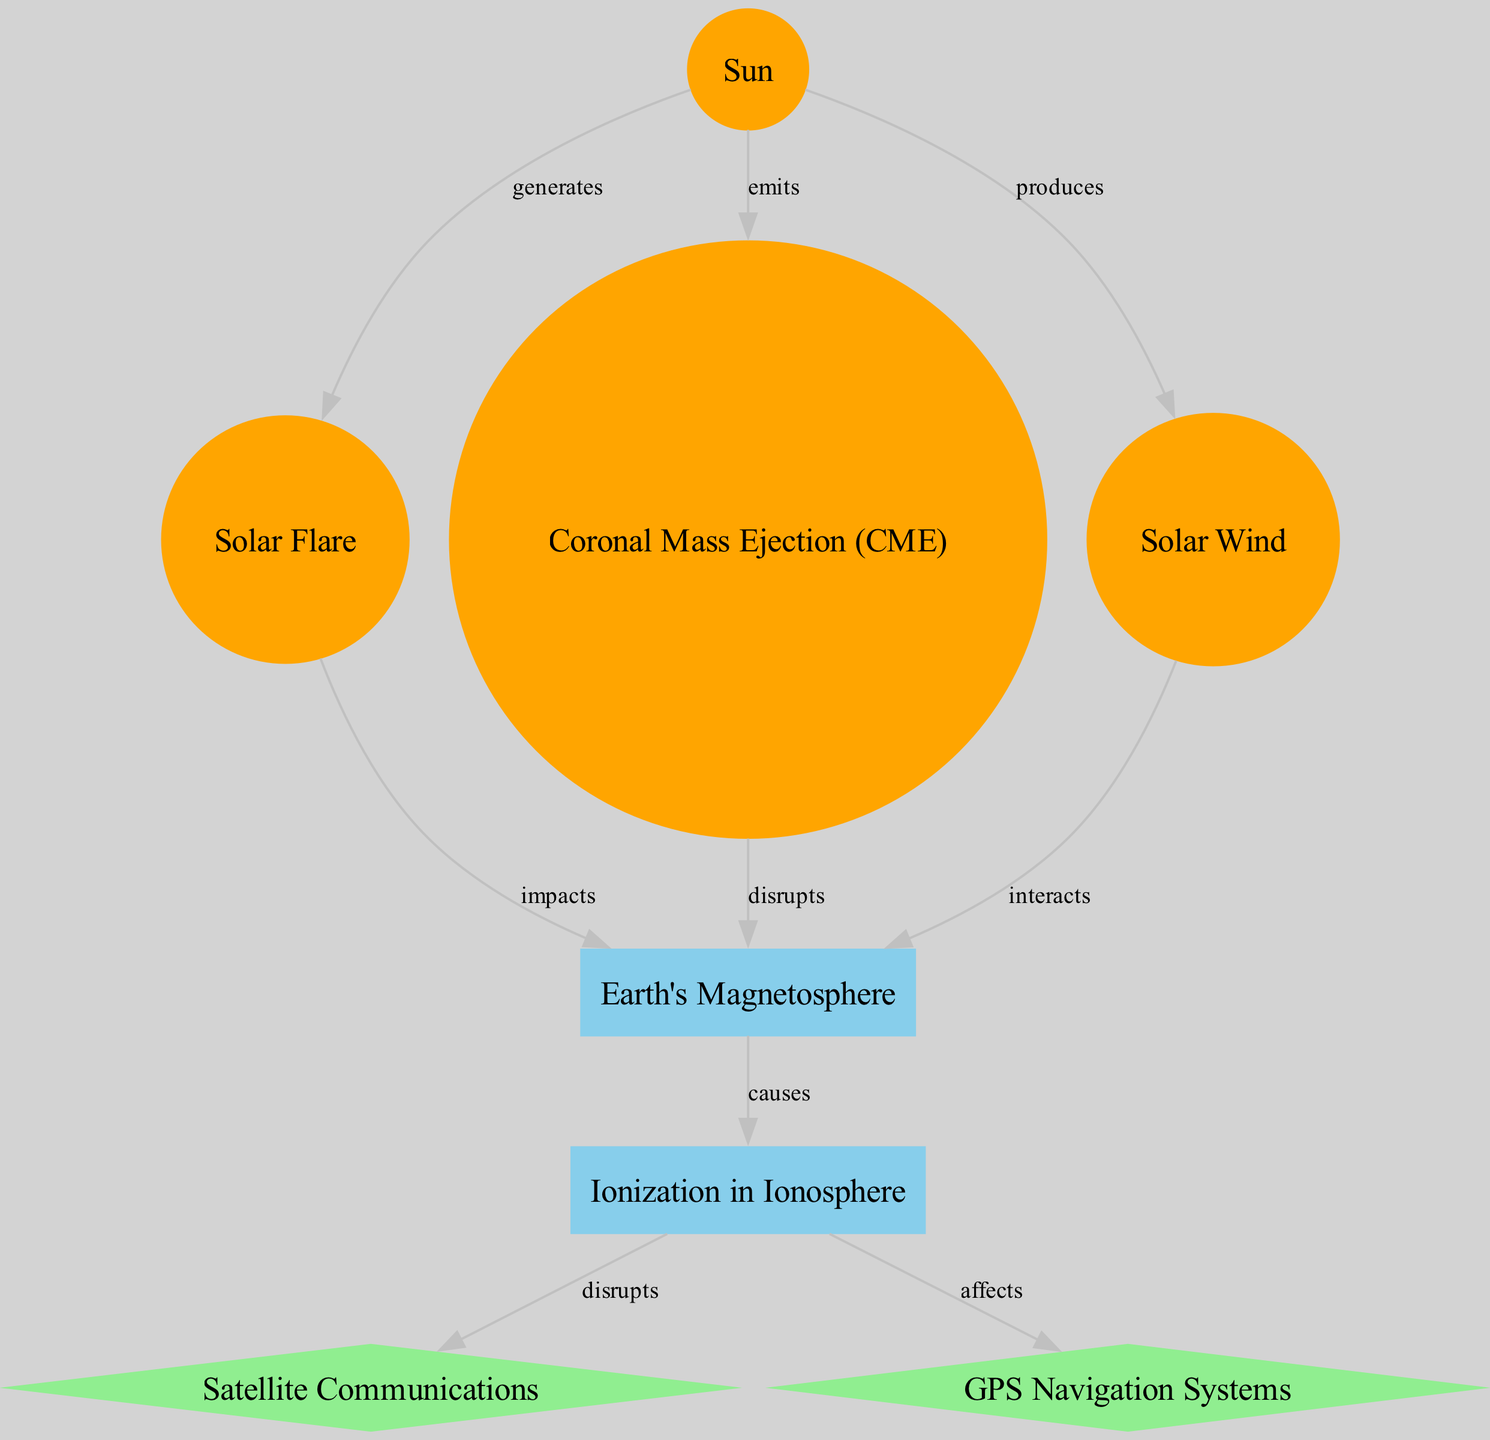What is the total number of nodes in the diagram? The diagram contains a list of nodes: Sun, Solar Flare, Coronal Mass Ejection (CME), Solar Wind, Earth's Magnetosphere, Ionization in Ionosphere, Satellite Communications, and GPS Navigation Systems. Counting these gives a total of 8 nodes.
Answer: 8 What is the relationship between Solar Flare and Earth's Magnetosphere? According to the diagram, Solar Flare impacts Earth's Magnetosphere. This is shown by the directed edge labeled "impacts" from Solar Flare to Earth's Magnetosphere.
Answer: impacts How many edges are there in the diagram? The diagram details connections between nodes, known as edges. By counting the edges listed, such as "generates," "emits," "produces," etc., we find that there are 9 edges in total.
Answer: 9 Which node is directly affected by Ionization in Ionosphere? The diagram shows that Ionization in Ionosphere disrupts two other nodes, specifically Satellite Communications and GPS Navigation Systems, as indicated by the edges.
Answer: Satellite Communications and GPS Navigation Systems What is produced by Solar Wind? The diagram denotes that Solar Wind interacts with Earth's Magnetosphere. The edge leading from Solar Wind to Earth's Magnetosphere has the label "interacts," indicating this specific production.
Answer: interacts Which phenomenon generates Solar Flare? The diagram indicates that the Sun generates Solar Flare, as evidenced by the directed edge from Sun to Solar Flare labeled "generates."
Answer: Sun What effect does Coronal Mass Ejection (CME) have on Earth's Magnetosphere? The diagram specifically states that Coronal Mass Ejection disrupts Earth's Magnetosphere. This is shown by the directed edge labeled "disrupts."
Answer: disrupts What is the relationship between Solar Wind and GPS Navigation Systems? The diagram illustrates that Solar Wind indirectly affects GPS Navigation Systems through its interaction with Earth's Magnetosphere, which causes ionization that affects GPS Navigation Systems.
Answer: affects through Interaction How does ionization occur in the Ionosphere? In the diagram, ionization occurs in the Ionosphere as a result of impacts and disruptions from other space weather phenomena affecting Earth's Magnetosphere. This could involve multiple pathways, including those from Solar Flares and Coronal Mass Ejections.
Answer: causes by Earth's Magnetosphere 